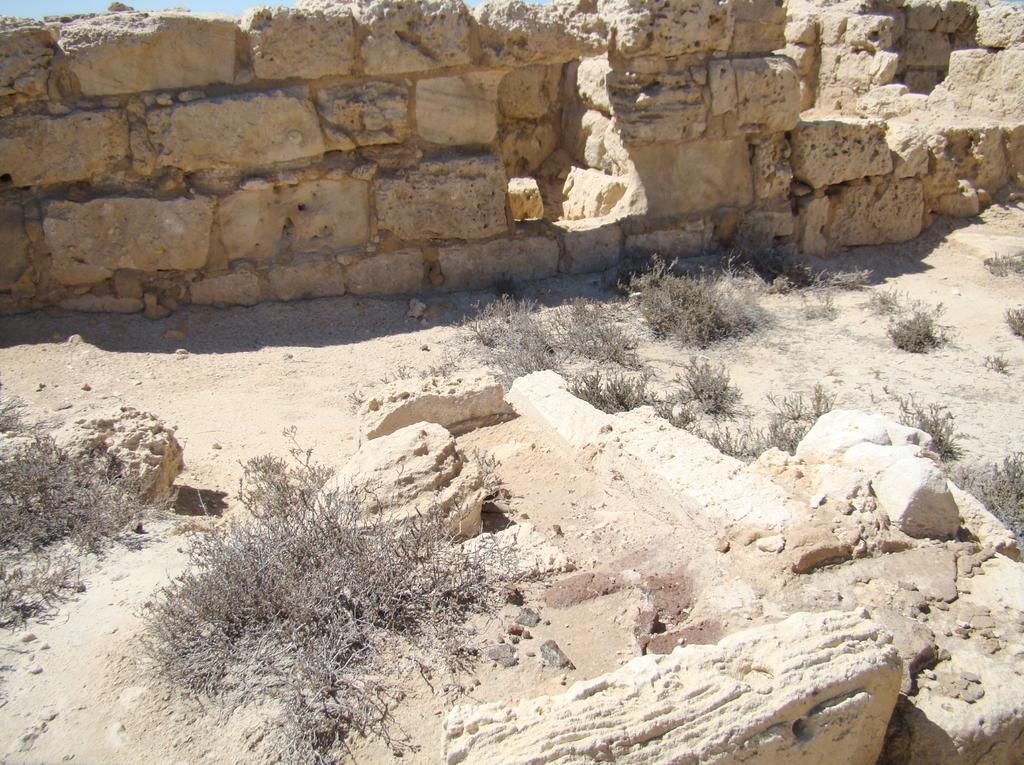What type of ground surface is visible in the image? There are stones and grass on the ground in the image. What is the wall in the background made of? The wall in the background is made of stones. What is visible at the top of the image? The sky is visible at the top of the image. Where is the office located in the image? There is no office present in the image. What type of oatmeal can be seen in the image? There is no oatmeal present in the image. 